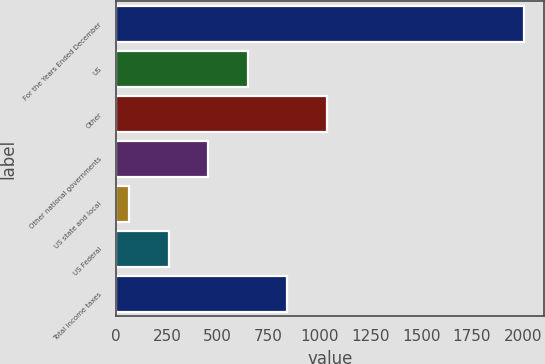Convert chart. <chart><loc_0><loc_0><loc_500><loc_500><bar_chart><fcel>For the Years Ended December<fcel>US<fcel>Other<fcel>Other national governments<fcel>US state and local<fcel>US Federal<fcel>Total income taxes<nl><fcel>2006<fcel>647.3<fcel>1035.5<fcel>453.2<fcel>65<fcel>259.1<fcel>841.4<nl></chart> 